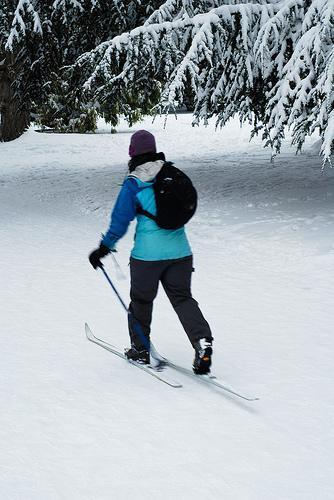How many people are in the photo?
Give a very brief answer. 1. How many skiers are pictured?
Give a very brief answer. 1. How many people are playing football?
Give a very brief answer. 0. 